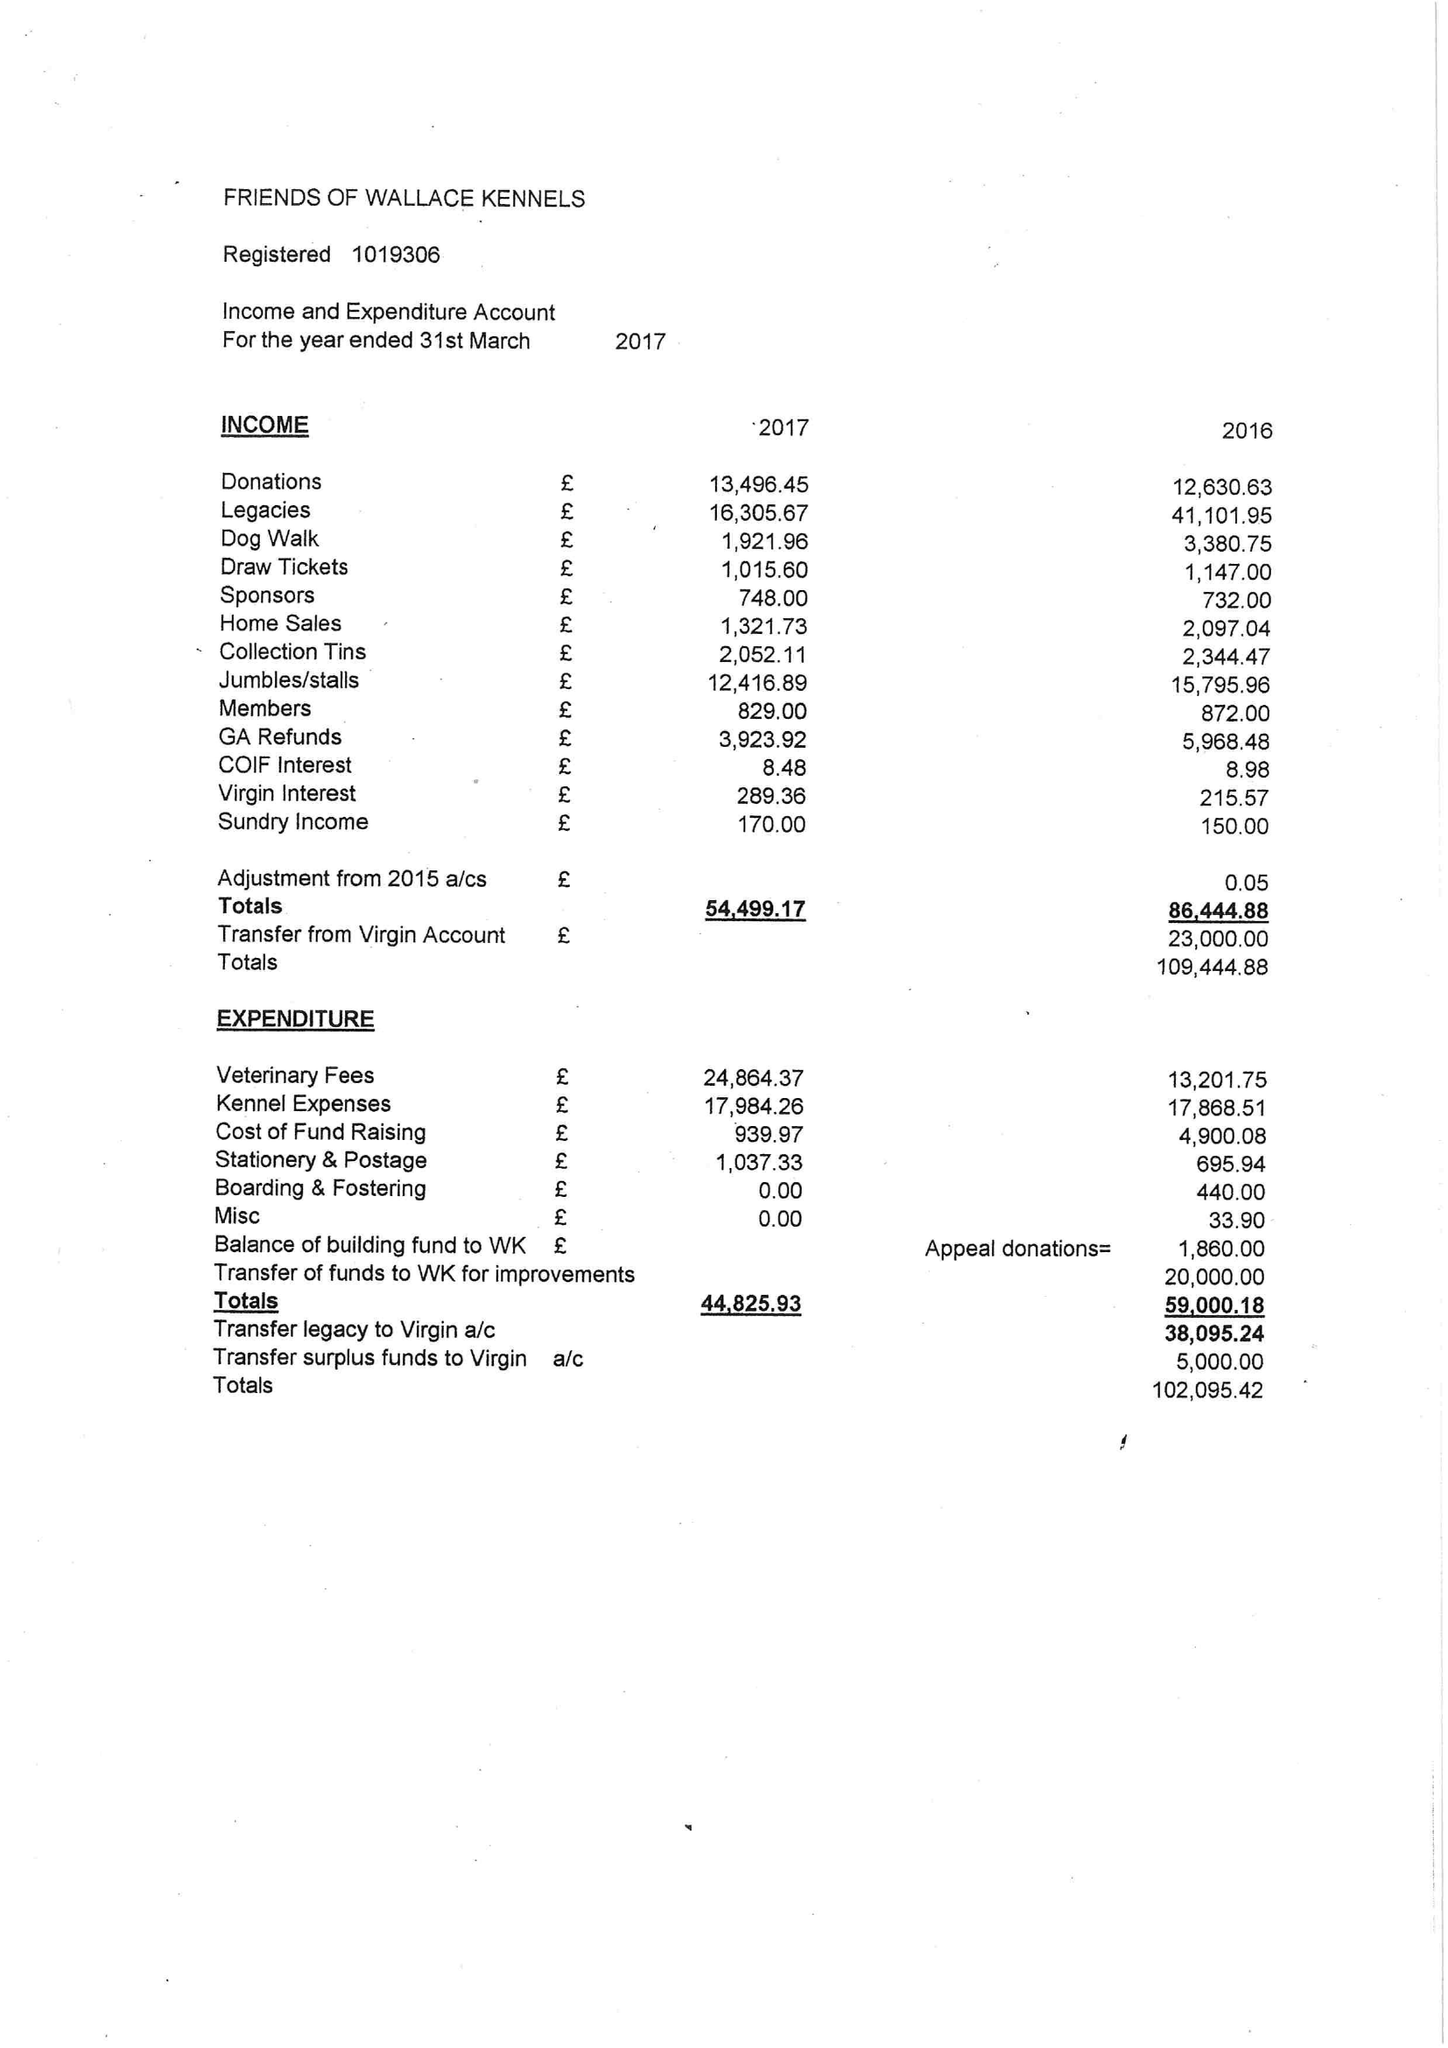What is the value for the income_annually_in_british_pounds?
Answer the question using a single word or phrase. 54499.00 